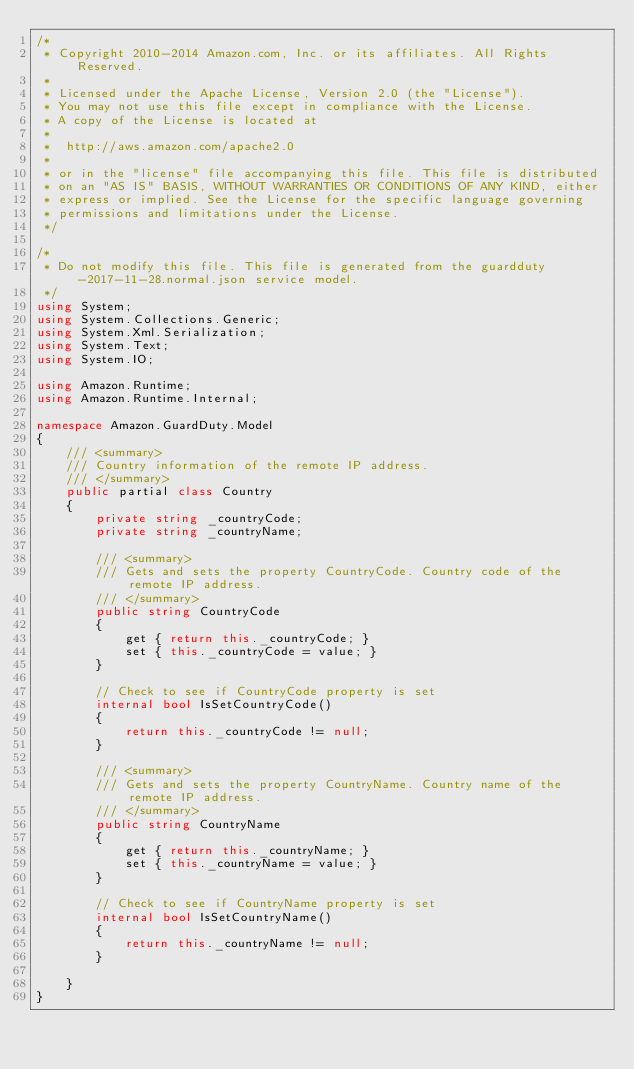<code> <loc_0><loc_0><loc_500><loc_500><_C#_>/*
 * Copyright 2010-2014 Amazon.com, Inc. or its affiliates. All Rights Reserved.
 * 
 * Licensed under the Apache License, Version 2.0 (the "License").
 * You may not use this file except in compliance with the License.
 * A copy of the License is located at
 * 
 *  http://aws.amazon.com/apache2.0
 * 
 * or in the "license" file accompanying this file. This file is distributed
 * on an "AS IS" BASIS, WITHOUT WARRANTIES OR CONDITIONS OF ANY KIND, either
 * express or implied. See the License for the specific language governing
 * permissions and limitations under the License.
 */

/*
 * Do not modify this file. This file is generated from the guardduty-2017-11-28.normal.json service model.
 */
using System;
using System.Collections.Generic;
using System.Xml.Serialization;
using System.Text;
using System.IO;

using Amazon.Runtime;
using Amazon.Runtime.Internal;

namespace Amazon.GuardDuty.Model
{
    /// <summary>
    /// Country information of the remote IP address.
    /// </summary>
    public partial class Country
    {
        private string _countryCode;
        private string _countryName;

        /// <summary>
        /// Gets and sets the property CountryCode. Country code of the remote IP address.
        /// </summary>
        public string CountryCode
        {
            get { return this._countryCode; }
            set { this._countryCode = value; }
        }

        // Check to see if CountryCode property is set
        internal bool IsSetCountryCode()
        {
            return this._countryCode != null;
        }

        /// <summary>
        /// Gets and sets the property CountryName. Country name of the remote IP address.
        /// </summary>
        public string CountryName
        {
            get { return this._countryName; }
            set { this._countryName = value; }
        }

        // Check to see if CountryName property is set
        internal bool IsSetCountryName()
        {
            return this._countryName != null;
        }

    }
}</code> 